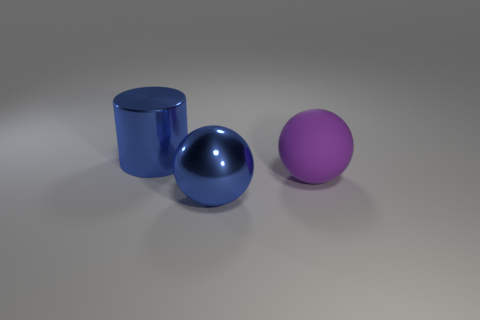Add 2 brown matte blocks. How many objects exist? 5 Subtract all blue balls. How many balls are left? 1 Subtract all cylinders. How many objects are left? 2 Subtract all gray balls. Subtract all gray cubes. How many balls are left? 2 Subtract all purple cylinders. How many purple balls are left? 1 Subtract all blue shiny cylinders. Subtract all tiny red spheres. How many objects are left? 2 Add 2 large purple rubber spheres. How many large purple rubber spheres are left? 3 Add 2 purple objects. How many purple objects exist? 3 Subtract 0 yellow balls. How many objects are left? 3 Subtract 1 cylinders. How many cylinders are left? 0 